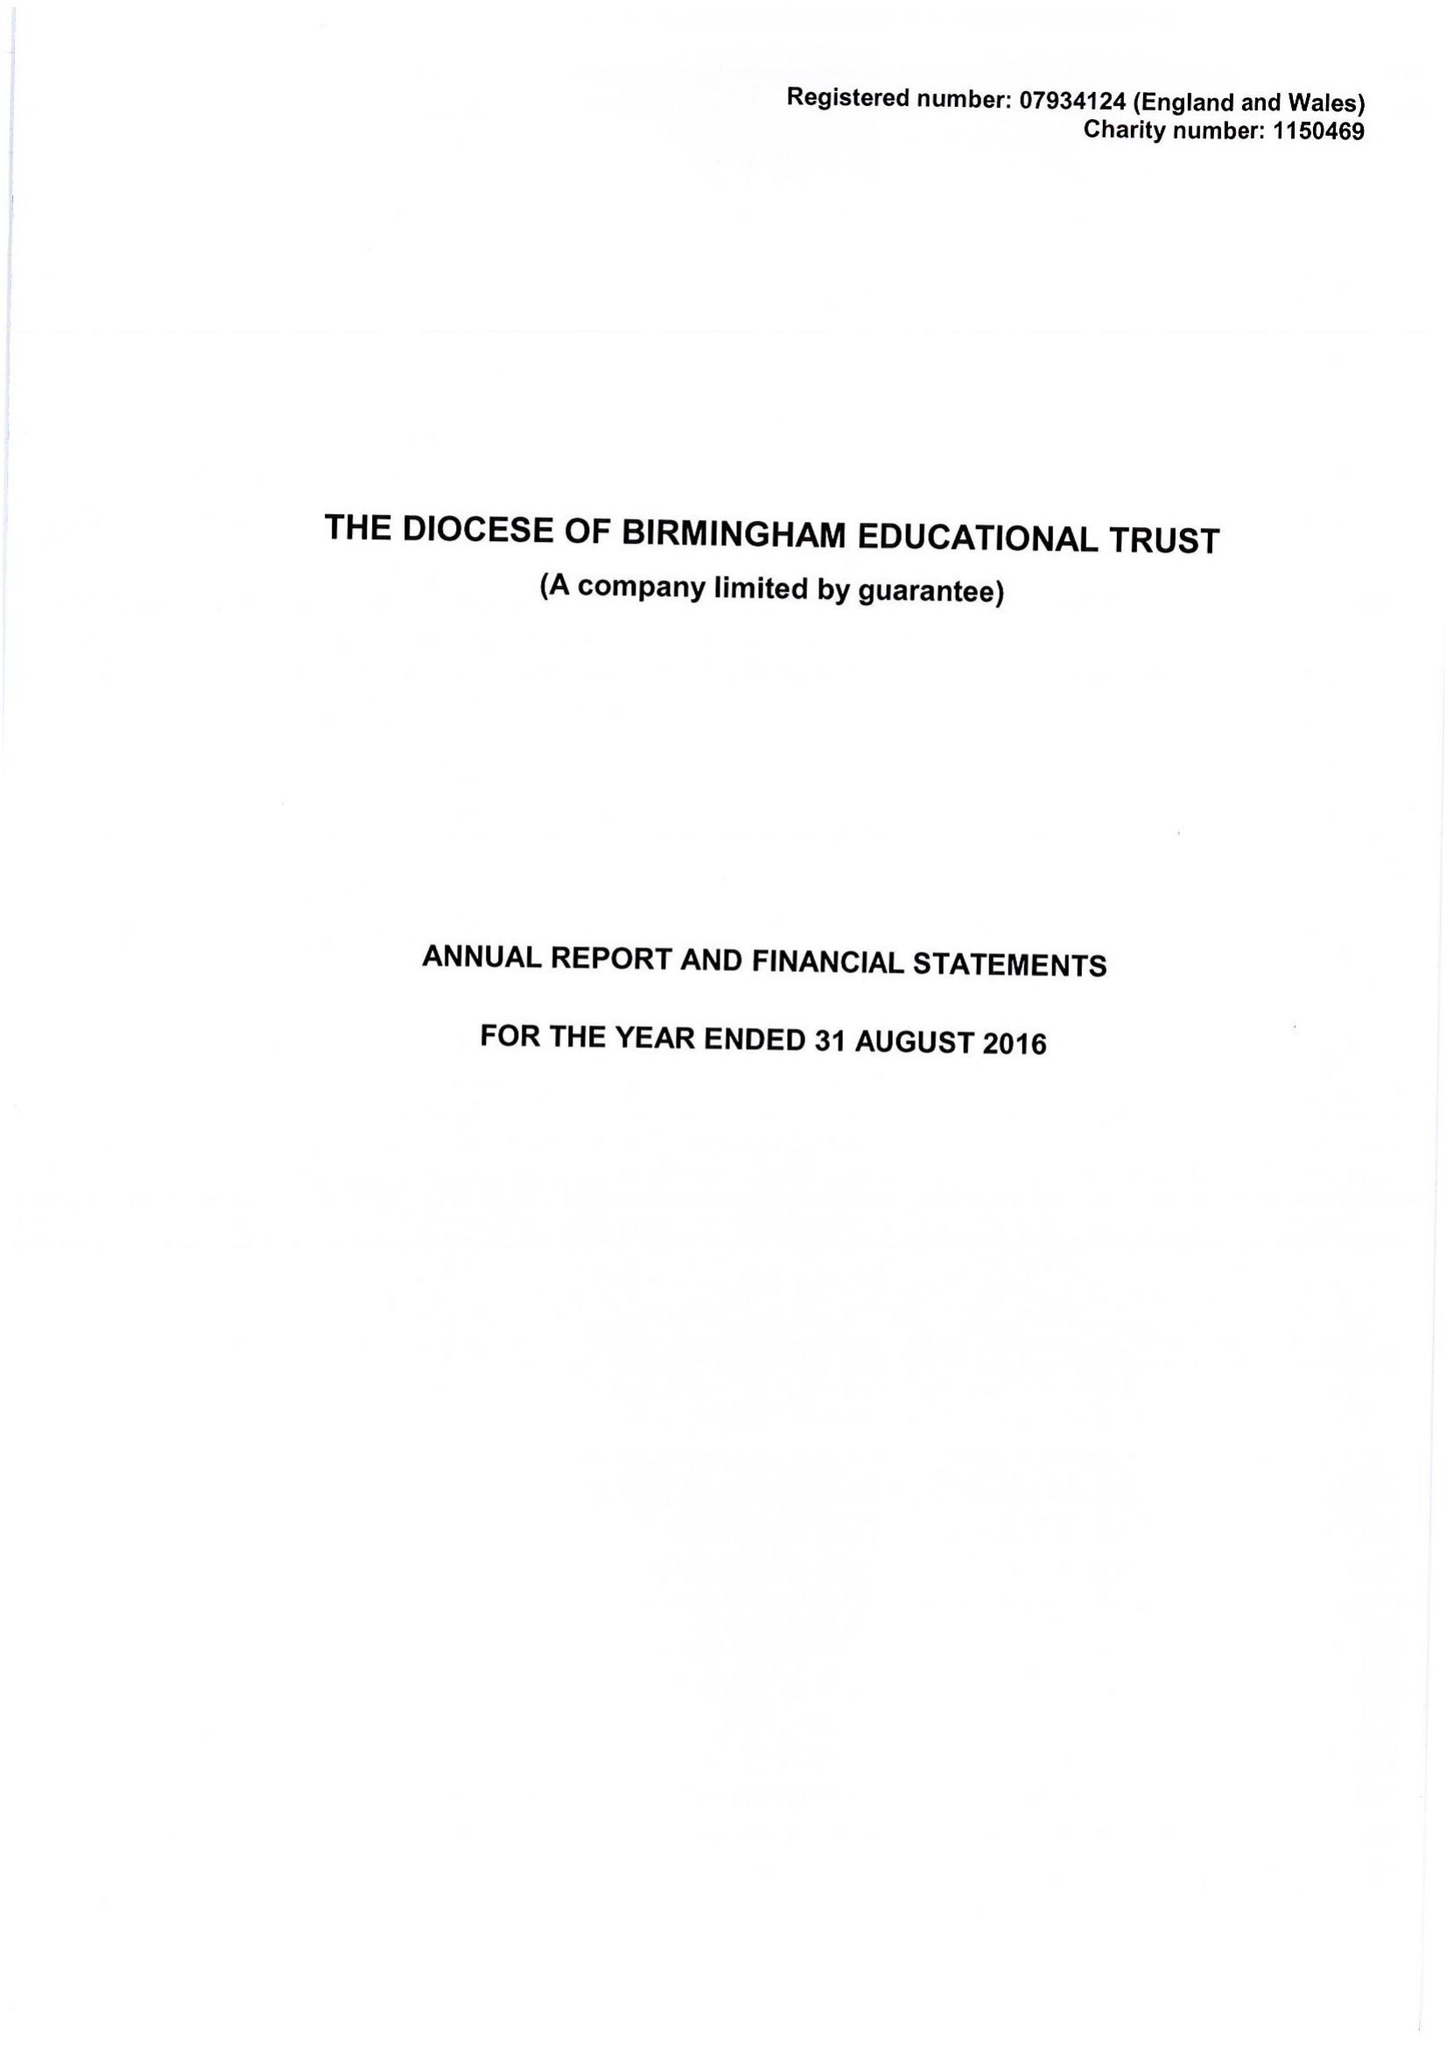What is the value for the income_annually_in_british_pounds?
Answer the question using a single word or phrase. 175675.00 